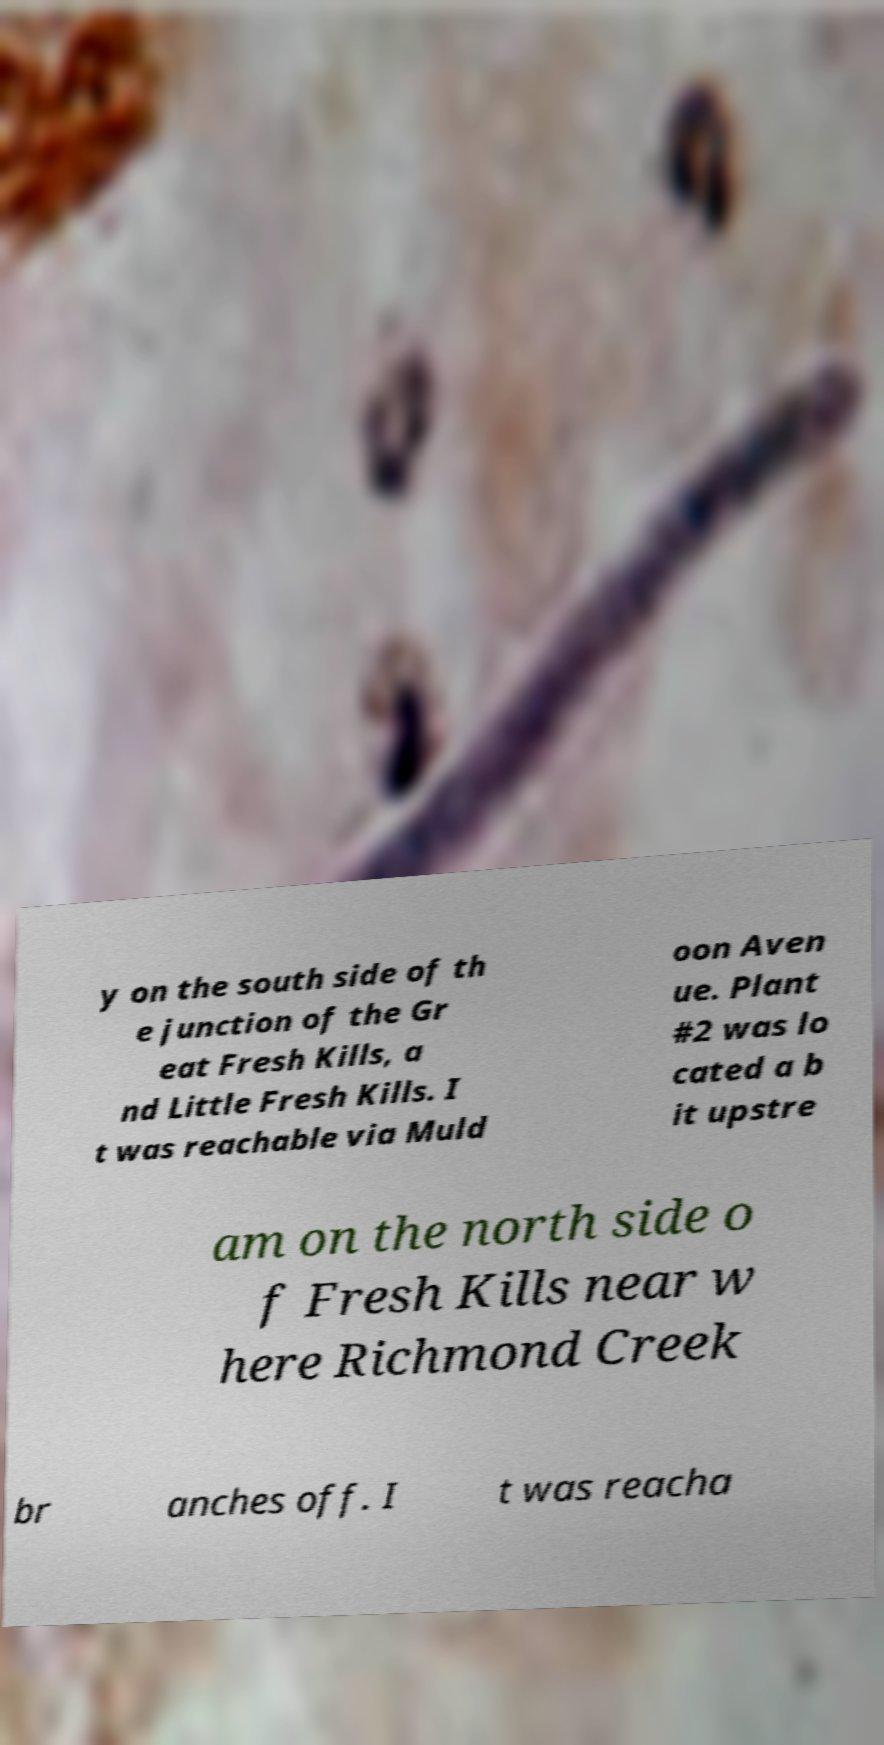I need the written content from this picture converted into text. Can you do that? y on the south side of th e junction of the Gr eat Fresh Kills, a nd Little Fresh Kills. I t was reachable via Muld oon Aven ue. Plant #2 was lo cated a b it upstre am on the north side o f Fresh Kills near w here Richmond Creek br anches off. I t was reacha 